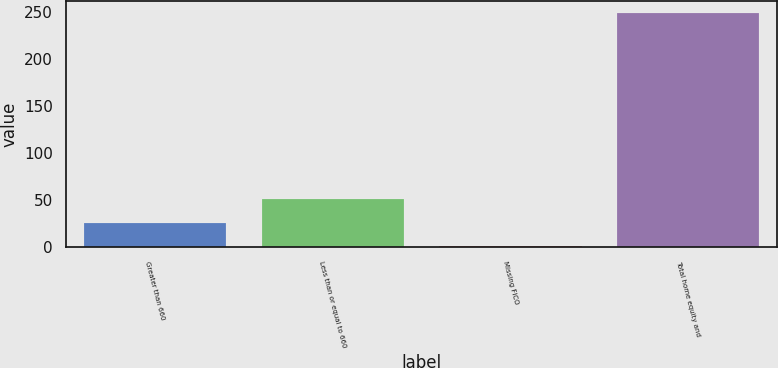Convert chart to OTSL. <chart><loc_0><loc_0><loc_500><loc_500><bar_chart><fcel>Greater than 660<fcel>Less than or equal to 660<fcel>Missing FICO<fcel>Total home equity and<nl><fcel>25.8<fcel>50.6<fcel>1<fcel>249<nl></chart> 